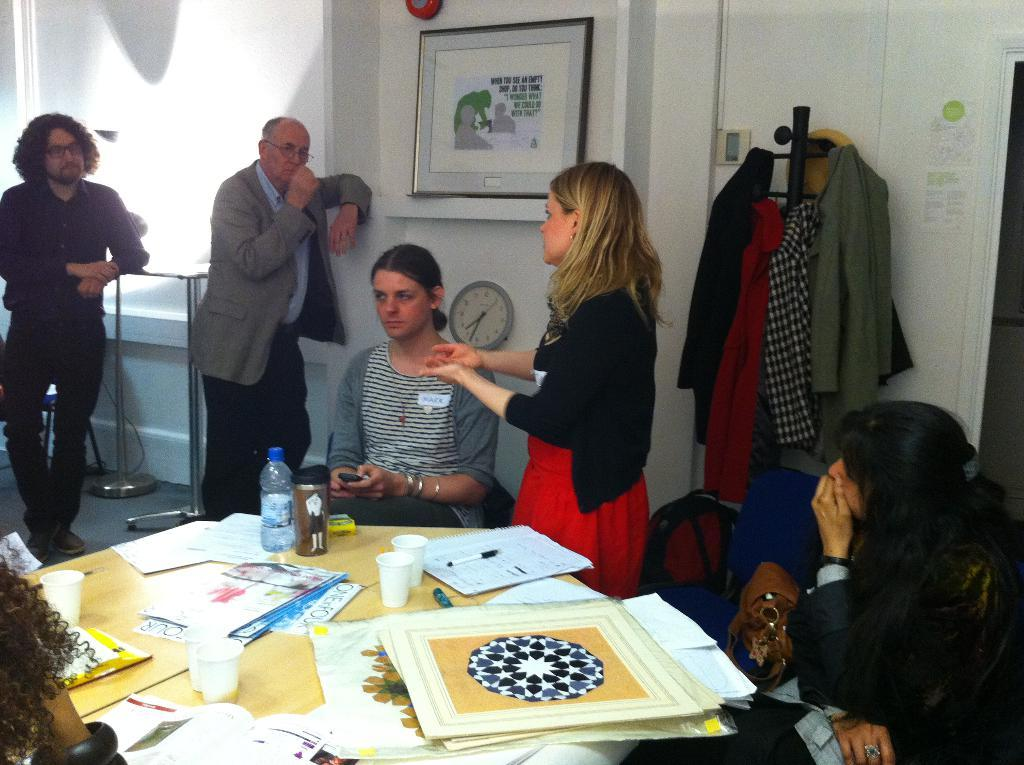What are the people in the image doing? The people in the image are sitting and standing in front of a table. What is on the table in the image? The table has papers on it, as well as other objects. Can you describe the other objects on the table? Unfortunately, the provided facts do not specify the other objects on the table. What type of grass is growing on the table in the image? There is no grass present on the table in the image. How many visitors are visible in the image? The provided facts do not mention any visitors in the image. 